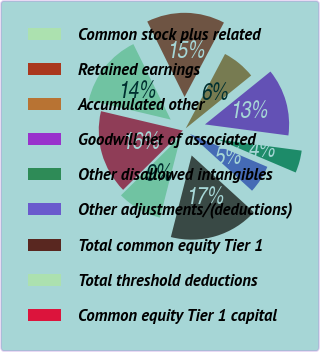Convert chart. <chart><loc_0><loc_0><loc_500><loc_500><pie_chart><fcel>Common stock plus related<fcel>Retained earnings<fcel>Accumulated other<fcel>Goodwill net of associated<fcel>Other disallowed intangibles<fcel>Other adjustments/(deductions)<fcel>Total common equity Tier 1<fcel>Total threshold deductions<fcel>Common equity Tier 1 capital<nl><fcel>13.98%<fcel>15.05%<fcel>6.45%<fcel>12.9%<fcel>4.3%<fcel>5.38%<fcel>17.2%<fcel>8.6%<fcel>16.13%<nl></chart> 